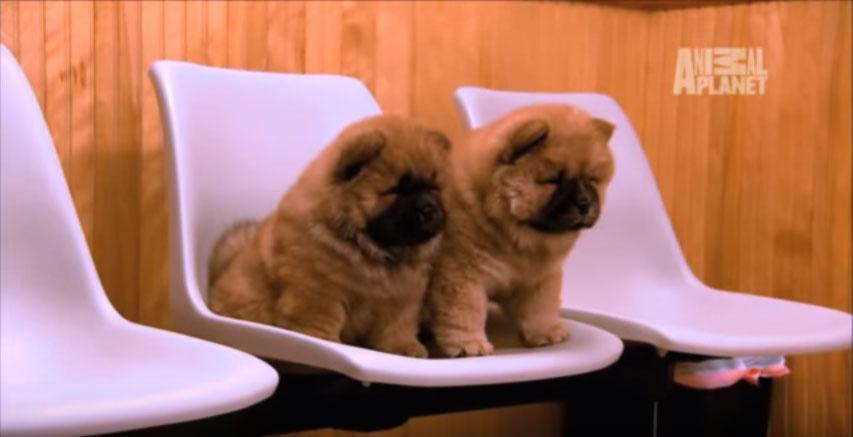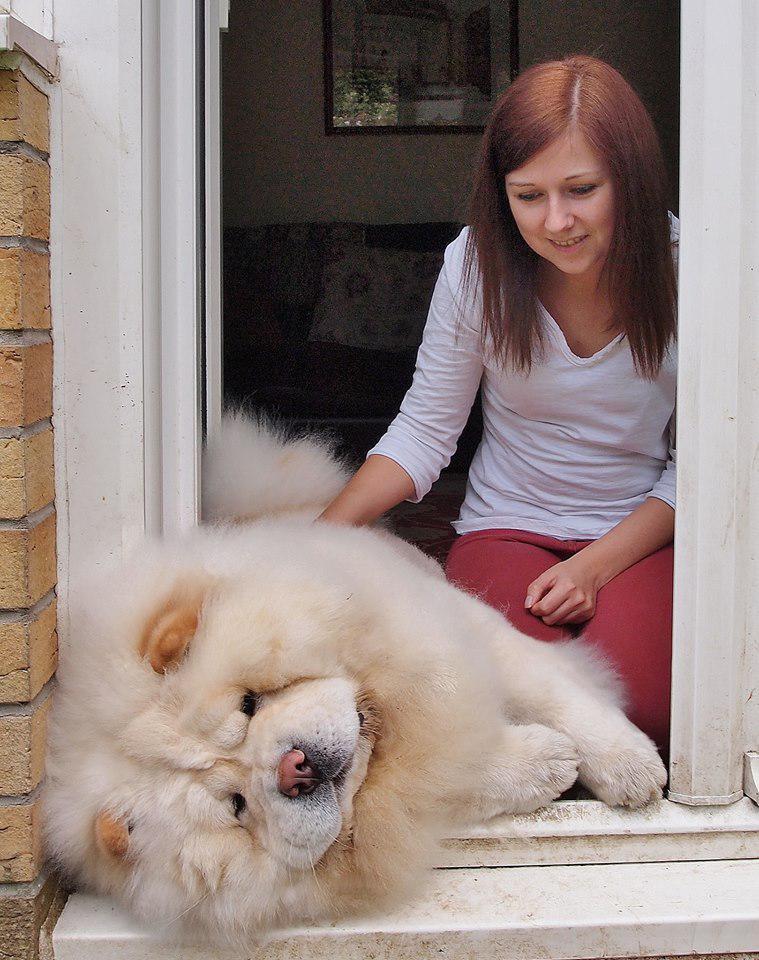The first image is the image on the left, the second image is the image on the right. Analyze the images presented: Is the assertion "There are exactly 3 dogs, and two of them are puppies." valid? Answer yes or no. Yes. The first image is the image on the left, the second image is the image on the right. Evaluate the accuracy of this statement regarding the images: "There are exactly three dogs in total.". Is it true? Answer yes or no. Yes. 